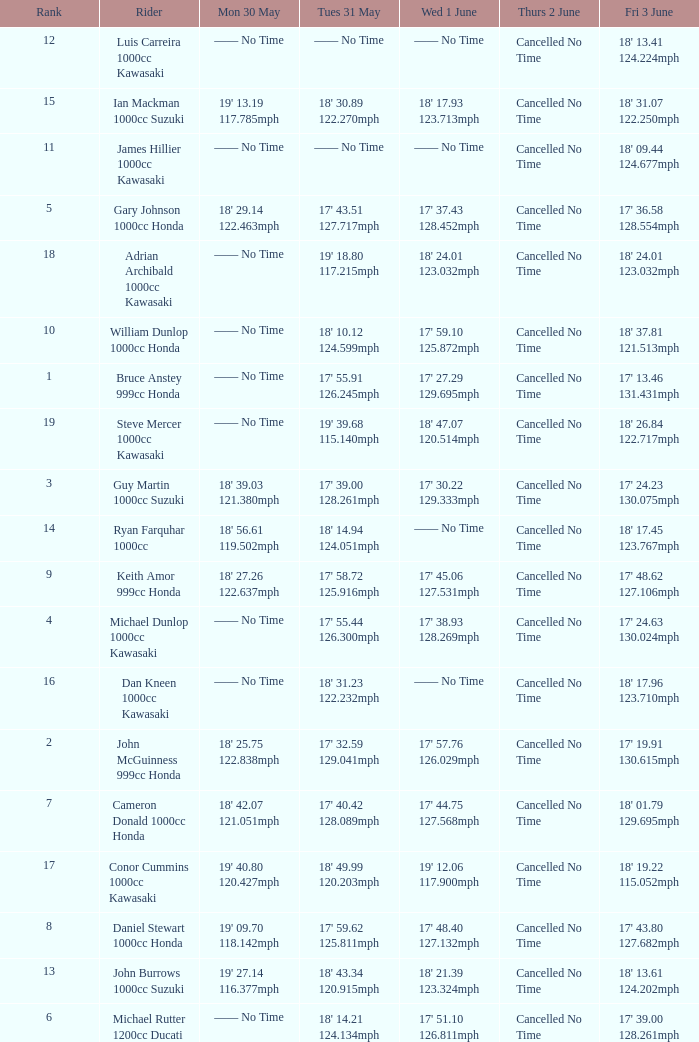What is the Thurs 2 June time for the rider with a Fri 3 June time of 17' 36.58 128.554mph? Cancelled No Time. 